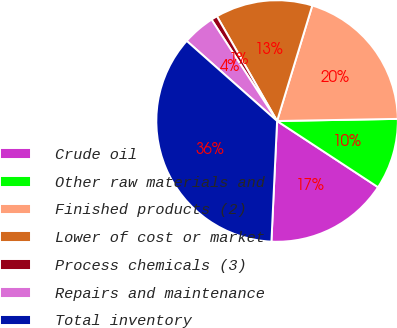Convert chart. <chart><loc_0><loc_0><loc_500><loc_500><pie_chart><fcel>Crude oil<fcel>Other raw materials and<fcel>Finished products (2)<fcel>Lower of cost or market<fcel>Process chemicals (3)<fcel>Repairs and maintenance<fcel>Total inventory<nl><fcel>16.51%<fcel>9.52%<fcel>20.01%<fcel>13.01%<fcel>0.83%<fcel>4.33%<fcel>35.79%<nl></chart> 